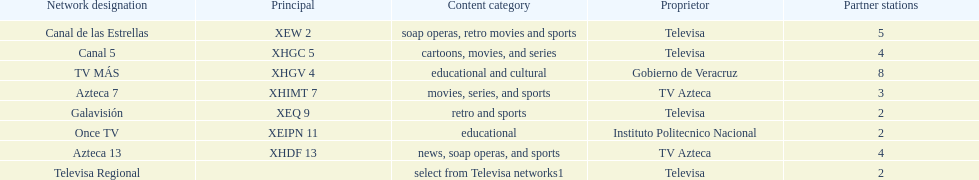Tell me the number of stations tv azteca owns. 2. 